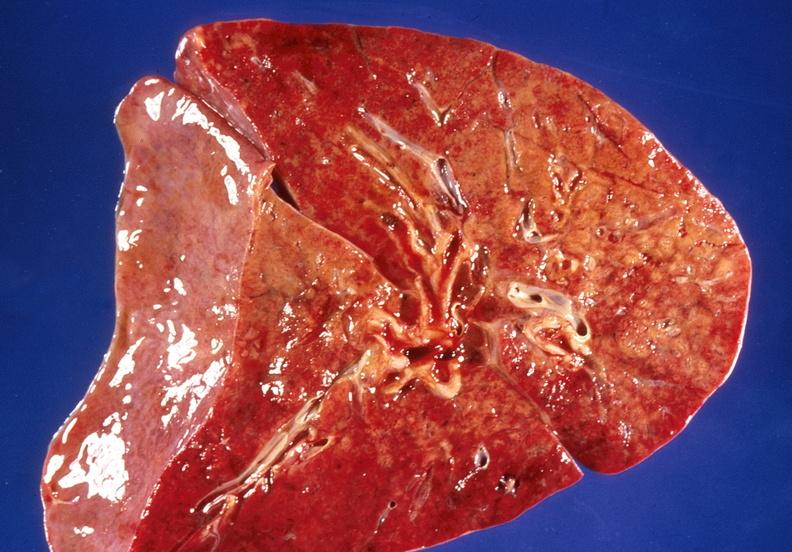what does this image show?
Answer the question using a single word or phrase. Lung 